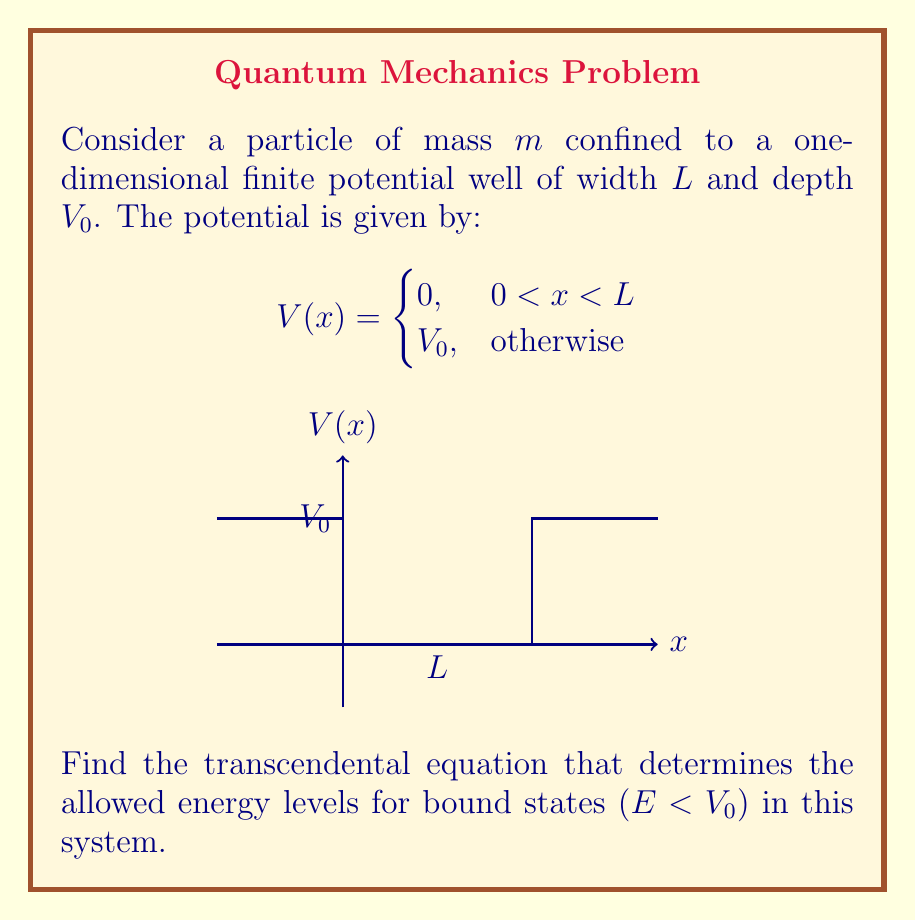Show me your answer to this math problem. To solve this problem, we'll follow these steps:

1) Inside the well (0 < x < L), the time-independent Schrödinger equation is:

   $$-\frac{\hbar^2}{2m}\frac{d^2\psi}{dx^2} = E\psi$$

   The general solution is:
   
   $$\psi_1(x) = A\sin(kx) + B\cos(kx)$$
   
   where $k = \sqrt{\frac{2mE}{\hbar^2}}$

2) Outside the well (x < 0 or x > L), the equation is:

   $$-\frac{\hbar^2}{2m}\frac{d^2\psi}{dx^2} + V_0\psi = E\psi$$

   The general solution is:
   
   $$\psi_2(x) = Ce^{\alpha x} + De^{-\alpha x}$$
   
   where $\alpha = \sqrt{\frac{2m(V_0-E)}{\hbar^2}}$

3) For bound states, we require $\psi \to 0$ as $x \to \pm\infty$. This means:

   For x < 0: $\psi_2(x) = De^{\alpha x}$
   For x > L: $\psi_2(x) = Ce^{-\alpha x}$

4) We need to match the wavefunctions and their derivatives at x = 0 and x = L:

   At x = 0: $D = B$ and $\alpha D = kA$
   At x = L: $A\sin(kL) + B\cos(kL) = Ce^{-\alpha L}$ and $k[A\cos(kL) - B\sin(kL)] = -\alpha Ce^{-\alpha L}$

5) Dividing the second equation by the first at each boundary:

   At x = 0: $\alpha = k\frac{A}{B}$
   At x = L: $k\frac{A\cos(kL) - B\sin(kL)}{A\sin(kL) + B\cos(kL)} = -\alpha$

6) Equating these and rearranging:

   $$k\frac{A}{B} = -k\frac{A\cos(kL) - B\sin(kL)}{A\sin(kL) + B\cos(kL)}$$

7) This simplifies to the transcendental equation:

   $$k\tan(kL) = \alpha$$

8) Substituting back the expressions for k and α:

   $$\sqrt{\frac{2mE}{\hbar^2}}\tan\left(\sqrt{\frac{2mE}{\hbar^2}}L\right) = \sqrt{\frac{2m(V_0-E)}{\hbar^2}}$$
Answer: $$\sqrt{E}\tan\left(\sqrt{\frac{2mE}{\hbar^2}}L\right) = \sqrt{V_0-E}$$ 